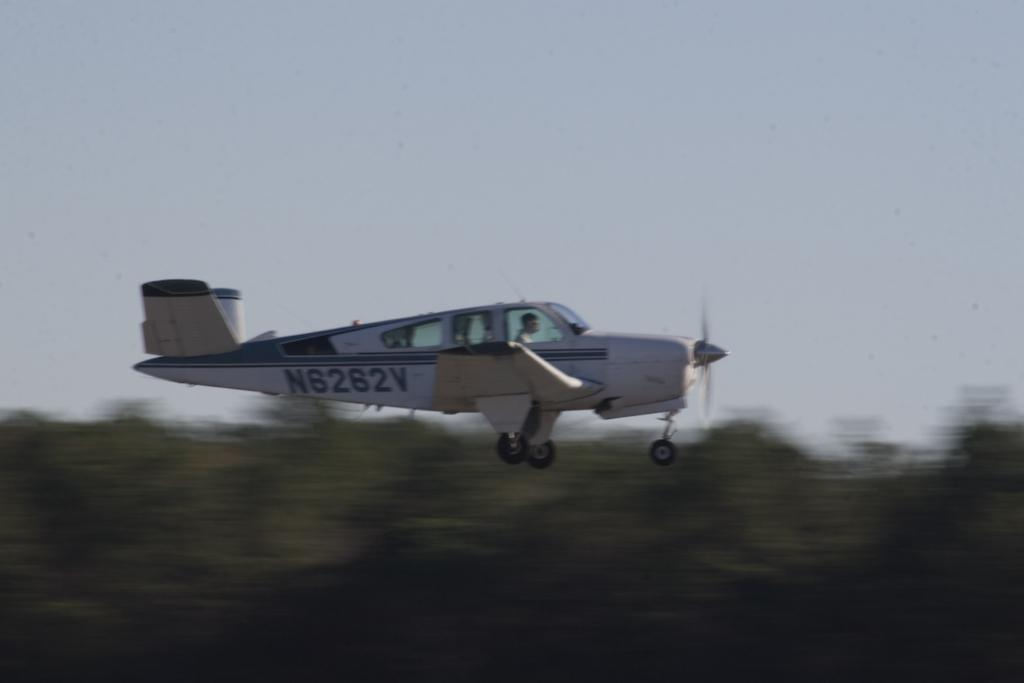What is the main subject of the image? The main subject of the image is an aircraft. Can you describe the person inside the aircraft? A person is sitting inside the aircraft. What can be observed about the background of the image? The background of the image is blurred. What is visible at the top of the image? The sky is visible at the top of the image. How many pieces of wax are scattered on the floor of the aircraft in the image? There is no mention of wax in the image, so it cannot be determined if any pieces are scattered on the floor. 